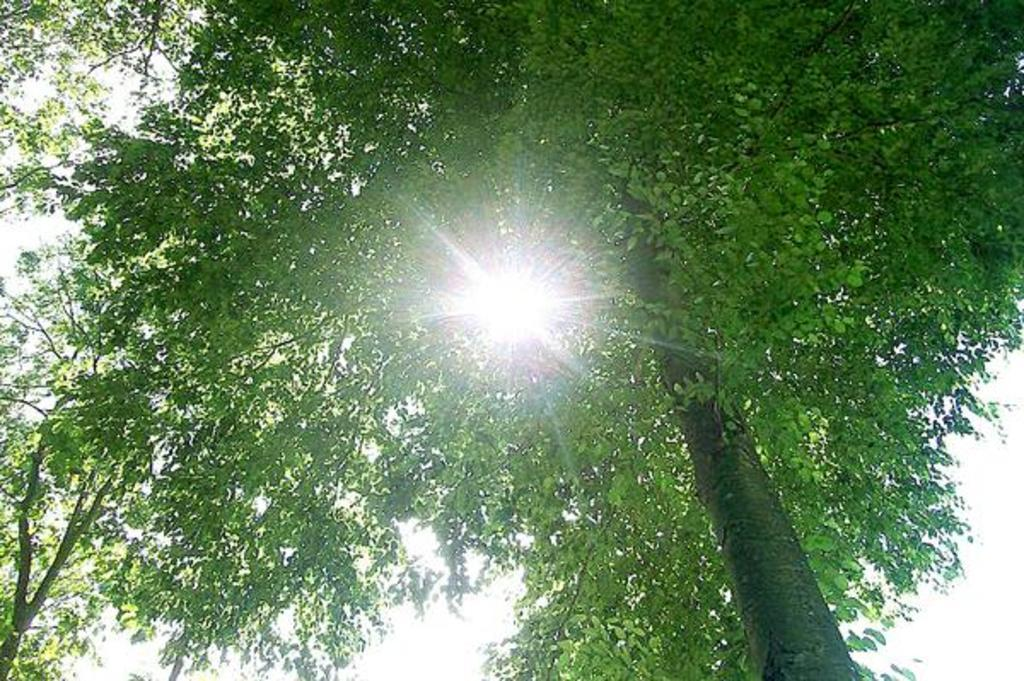What type of vegetation can be seen in the image? There are trees in the image. What is visible in the sky in the image? The sky is visible in the image. Can the sun be seen in the image? Yes, the sun is observable in the image. What type of ring can be seen on the tree in the image? There is no ring present on the tree in the image. What form does the sun take in the image? The sun appears as a bright, circular object in the image. 